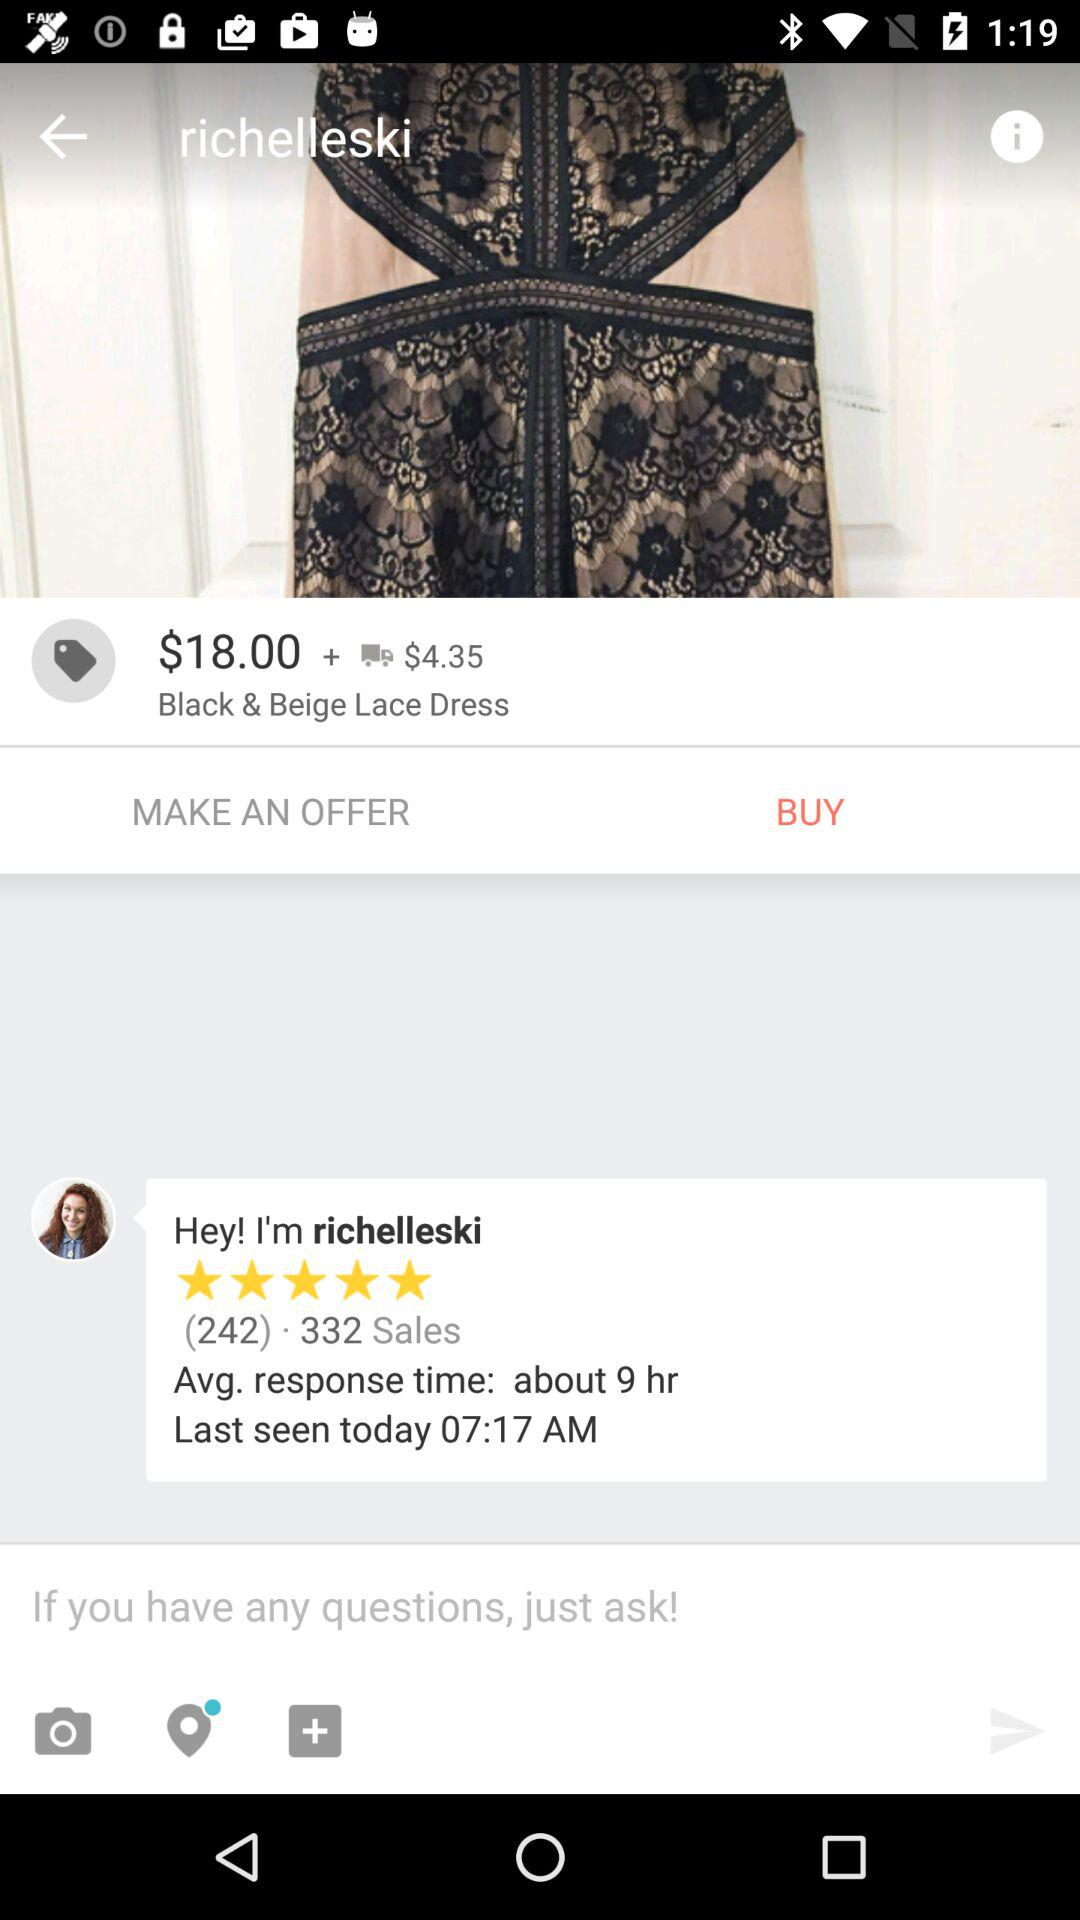What is the currency of the Price of the "Black & Beige Lace Dress"? The currency of the price is dollars. 